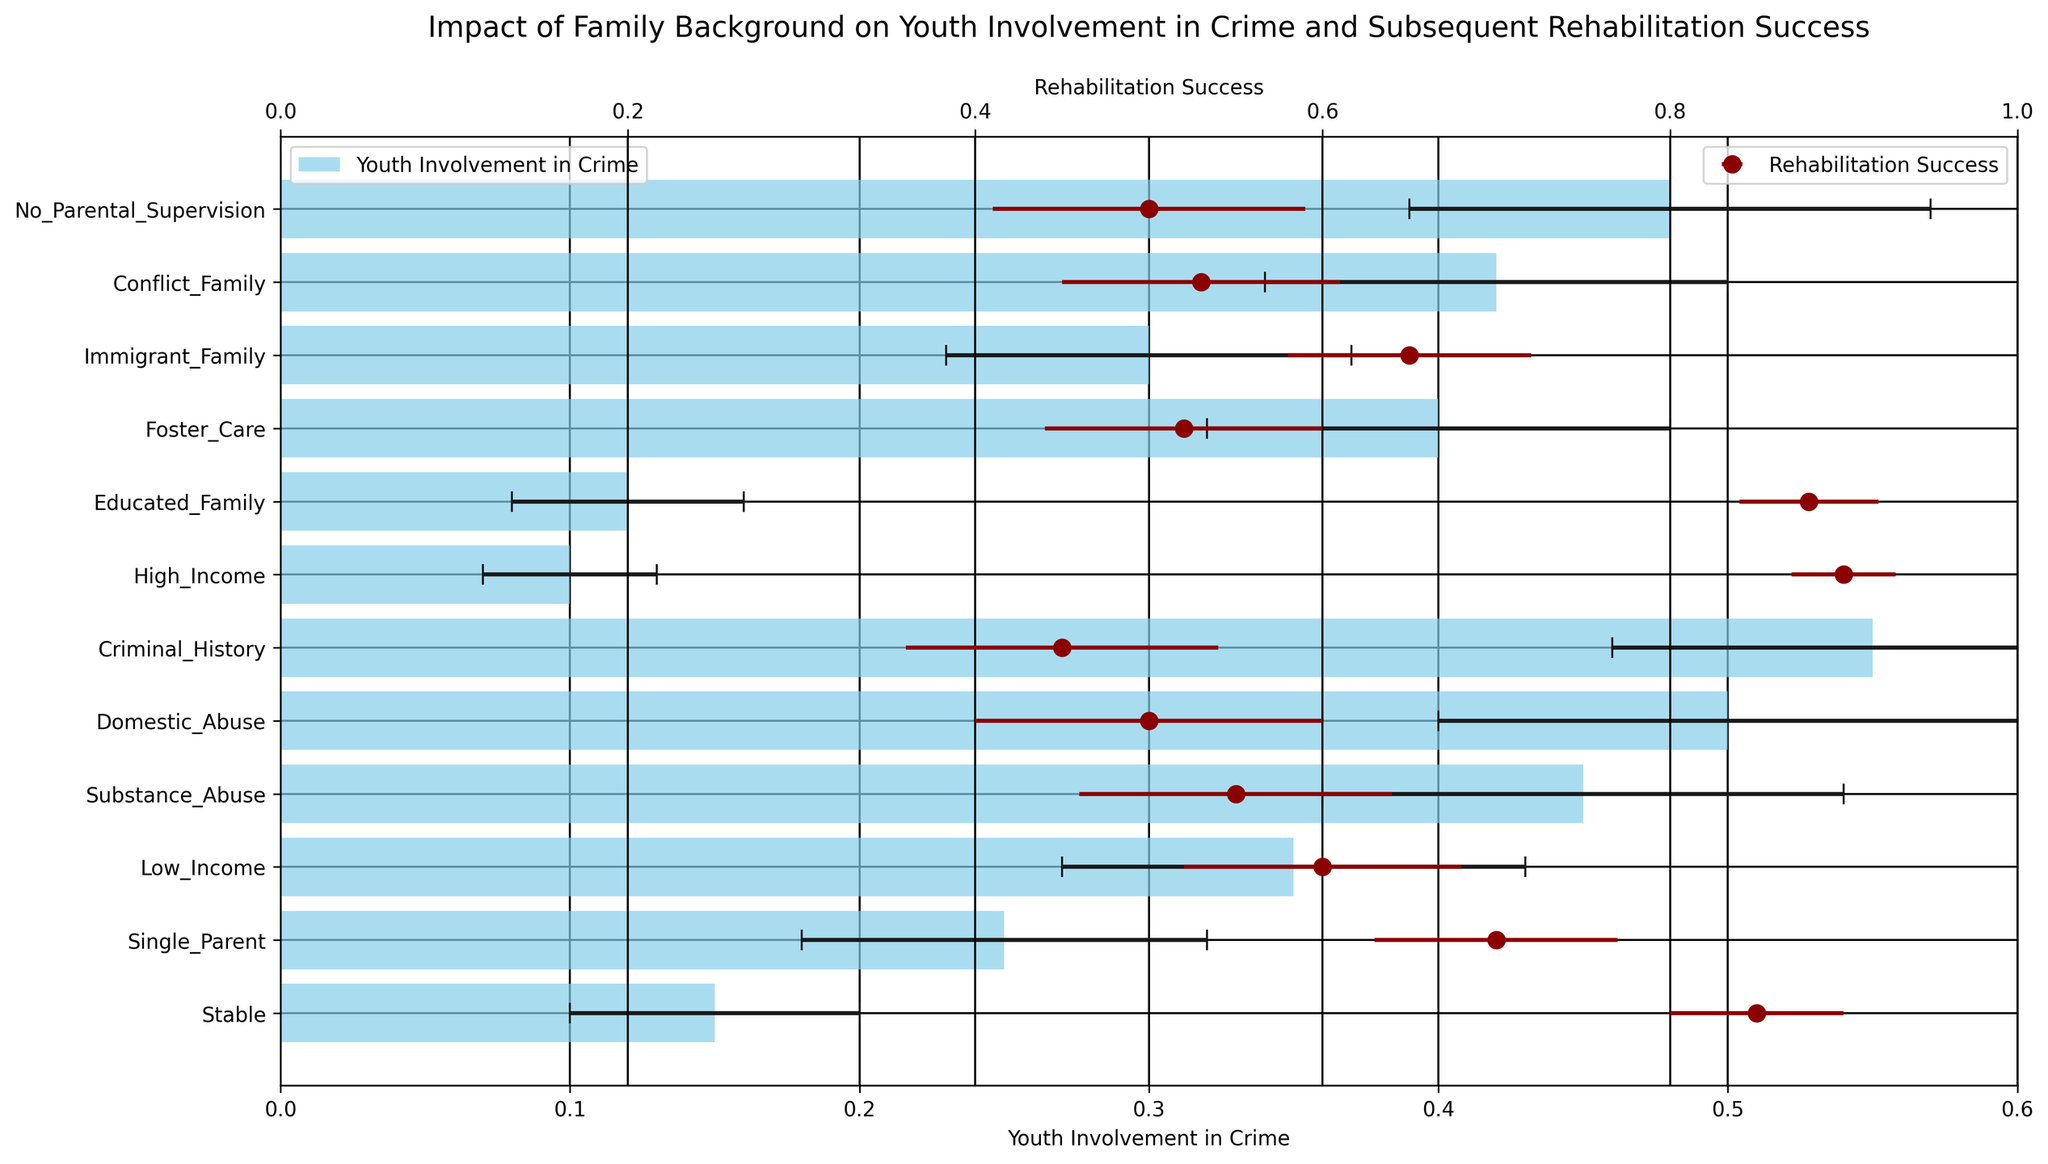How does youth involvement in crime compare between stable and high-income family backgrounds? Youth involvement in crime for a stable family background is 0.15, while for a high-income family background, it is 0.10. By comparing these values, youth involvement in crime is slightly higher in a stable family background than in a high-income family background.
Answer: Stable: 0.15, High-Income: 0.10 Which family background has the highest rehabilitation success rate, and what is that rate? To answer this, we look for the family background with the highest rehabilitation success value. Educated Family has the highest rehabilitation success rate of 0.88.
Answer: Educated Family, 0.88 What is the difference in rehabilitation success rates between single-parent and substance-abuse backgrounds? Rehabilitation success for a single-parent background is 0.70, and for a substance-abuse background, it is 0.55. The difference is found by subtracting these values: 0.70 - 0.55 = 0.15.
Answer: 0.15 Among the family backgrounds listed, which shows the lowest youth involvement in crime, and what is the corresponding value? The lowest value for youth involvement in crime appears under the high-income family background, which is 0.10.
Answer: High-Income, 0.10 How do the error margins for criminal history and domestic-abuse backgrounds compare in terms of youth involvement in crime? The error margin for youth involvement in crime is 0.09 for a criminal history and 0.10 for domestic abuse. The error margin is slightly larger for the domestic-abuse background.
Answer: Criminal History: 0.09, Domestic Abuse: 0.10 Considering both crime involvement and rehabilitation success, which family background shows closely matched numbers? A close match between figures for crime involvement and rehabilitation success can be seen in the domestic-abuse background: crime involvement is 0.50 and rehabilitation success is also 0.50.
Answer: Domestic Abuse: 0.50 (crime involvement), 0.50 (rehabilitation success) How do youth involvement in crime and rehabilitation success for foster care compare to a low-income family background? Youth involvement in crime for foster care is 0.40, while for a low-income background, it is 0.35. Rehabilitation success for foster care is 0.52, and for low-income, it is 0.60. Foster care has higher crime involvement and lower rehabilitation success compared to a low-income background.
Answer: Foster Care: 0.40 (crime), 0.52 (rehab); Low-Income: 0.35 (crime), 0.60 (rehab) Which family background shows the least error margin in youth involvement in crime, and what is that margin? The least error margin in youth involvement in crime is seen with the high-income family background at 0.03.
Answer: High-Income, 0.03 